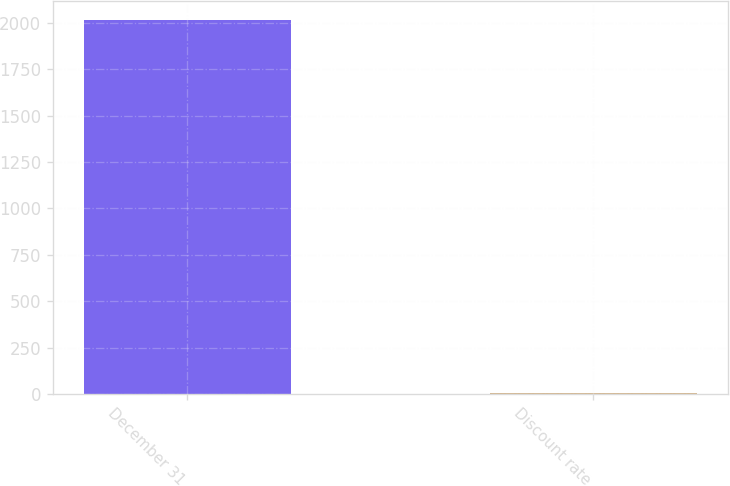Convert chart to OTSL. <chart><loc_0><loc_0><loc_500><loc_500><bar_chart><fcel>December 31<fcel>Discount rate<nl><fcel>2017<fcel>3.5<nl></chart> 